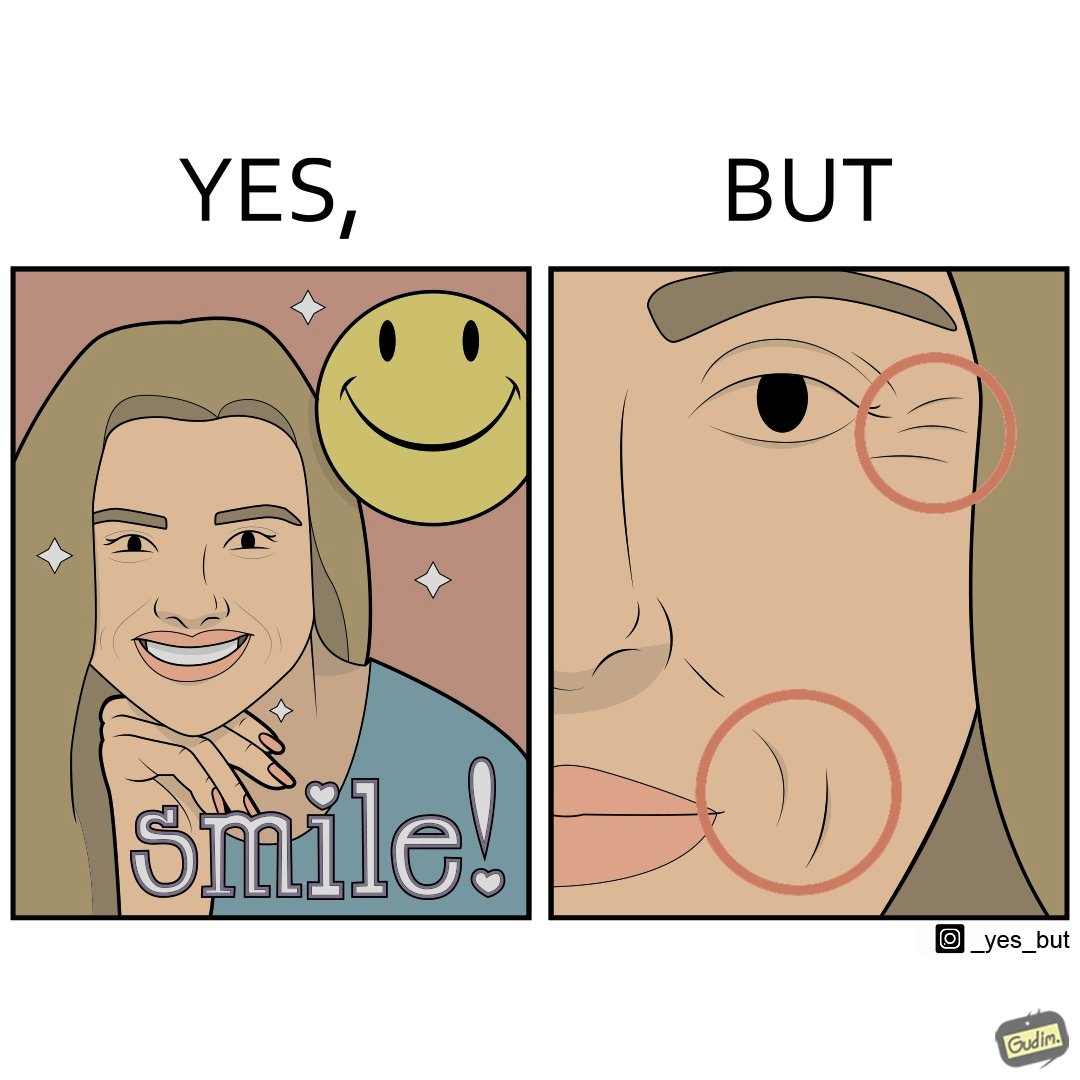Is this a satirical image? Yes, this image is satirical. 